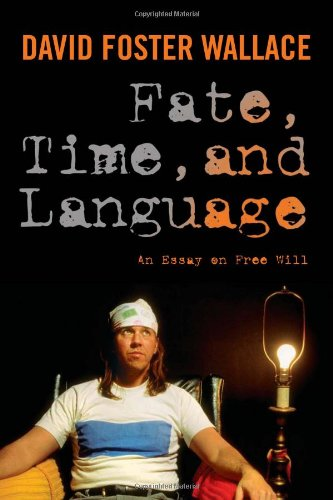Who wrote this book?
Answer the question using a single word or phrase. David Foster Wallace What is the title of this book? Fate, Time, and Language: An Essay on Free Will What is the genre of this book? Politics & Social Sciences Is this a sociopolitical book? Yes Is this a games related book? No 